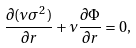Convert formula to latex. <formula><loc_0><loc_0><loc_500><loc_500>\frac { \partial ( \nu \sigma ^ { 2 } ) } { \partial r } + \nu \frac { \partial \Phi } { \partial r } = 0 ,</formula> 